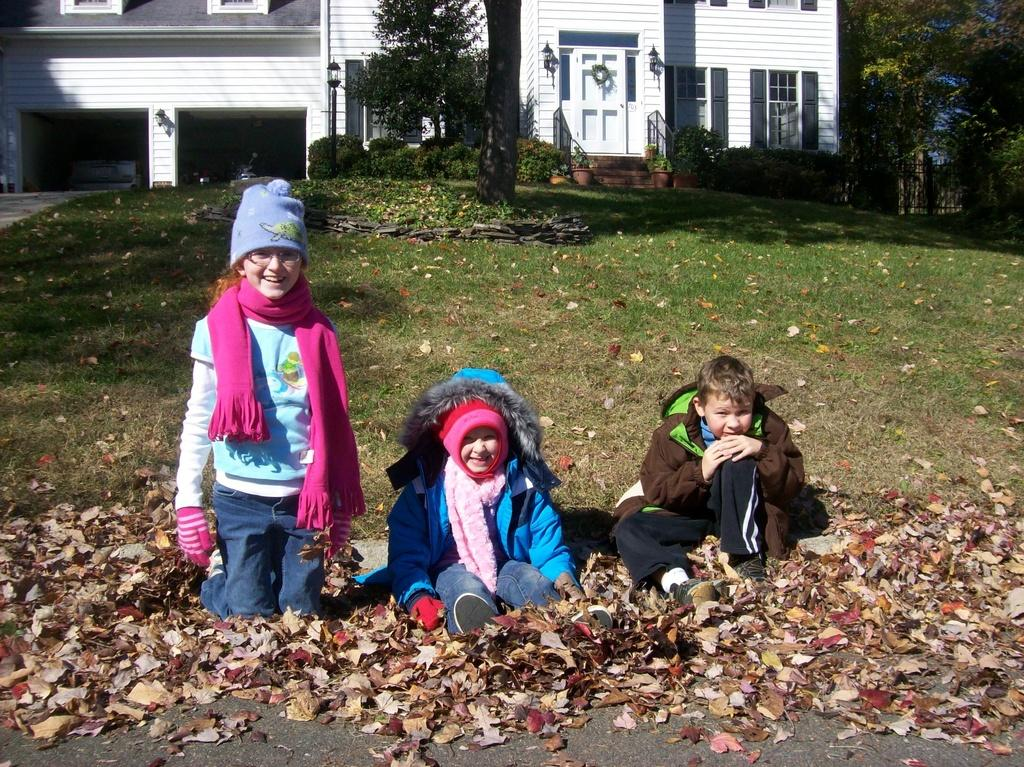How many children are sitting in the middle of the image? There are three children sitting in the middle of the image. What expression do the children have? The children are smiling. What type of vegetation is visible behind the children? There is grass, plants, and trees visible behind the children. What type of structure is visible behind the children? There is a building visible behind the children. What is present at the bottom of the image? There are leaves at the bottom of the image. Who is the manager of the children in the image? There is no indication of a manager or any supervisory role in the image. 